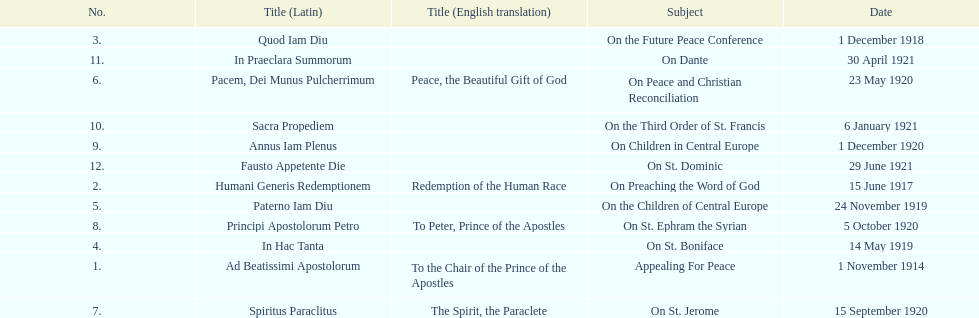How many titles did not list an english translation? 7. 